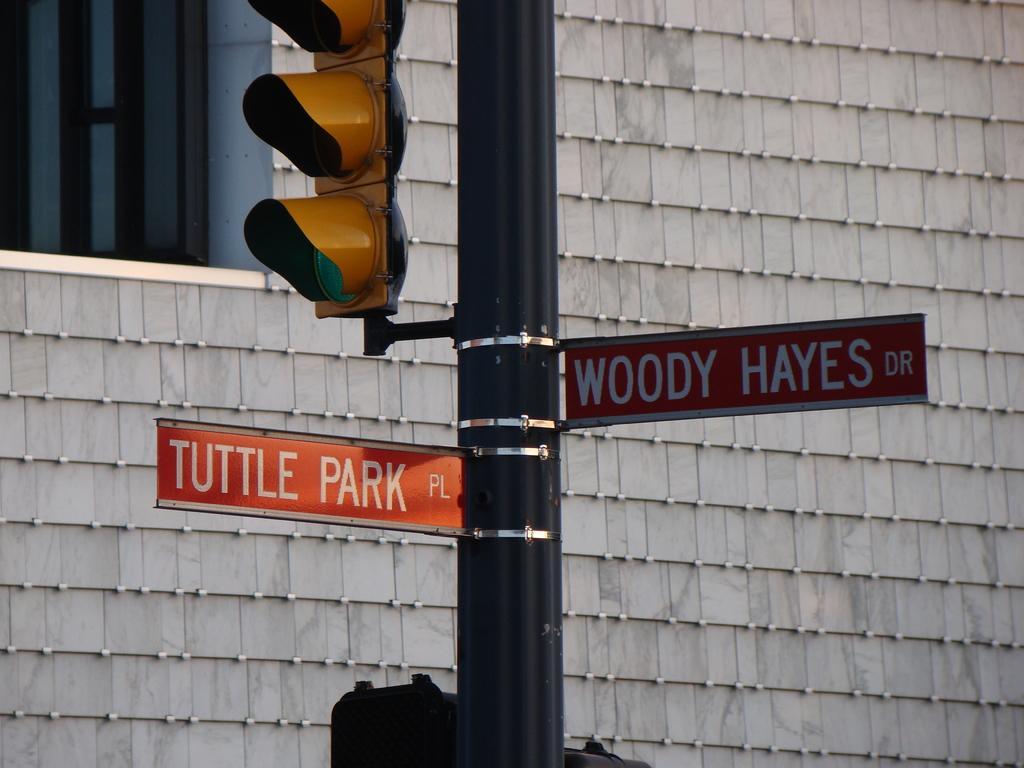Please provide a concise description of this image. n the image there is a pole in the middle with name board and traffic light on it and behind it there is a wall with window on the left side. 